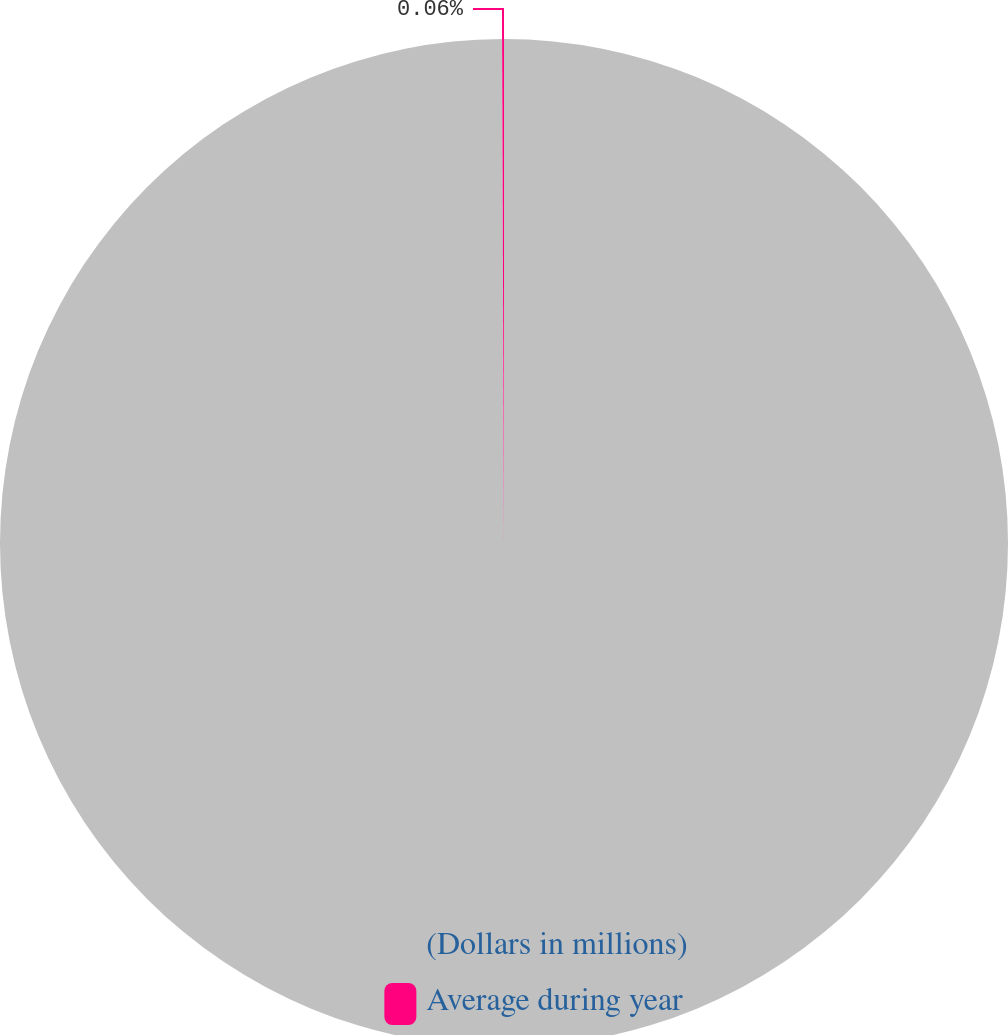Convert chart to OTSL. <chart><loc_0><loc_0><loc_500><loc_500><pie_chart><fcel>(Dollars in millions)<fcel>Average during year<nl><fcel>99.94%<fcel>0.06%<nl></chart> 